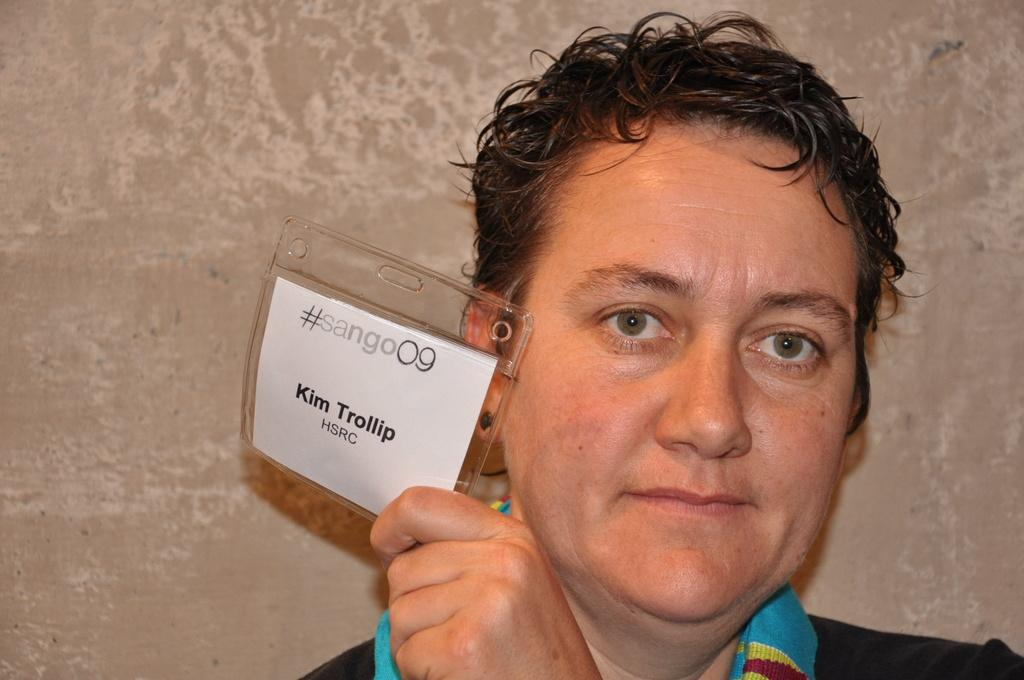What is present in the image? There is a person in the image. Can you describe what the person is wearing? The person is wearing a black dress. What is the person holding in their hand? The person is holding a card in their hand. What type of arithmetic problem is the person solving in the image? There is no arithmetic problem visible in the image. Does the person in the image express any feelings of hate? The image does not provide any information about the person's feelings or emotions. 